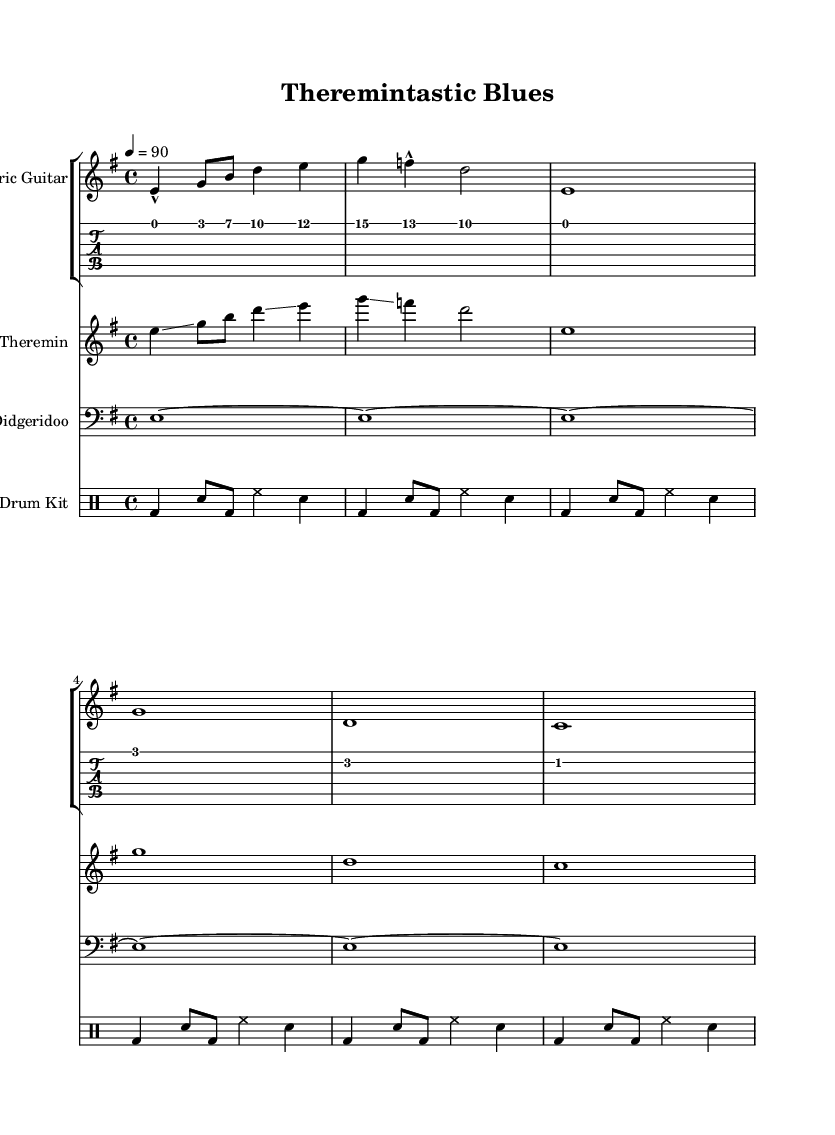What is the key signature of this music? The key signature is E minor, which contains one sharp (F#). This can be identified in the key signature section at the beginning of the score.
Answer: E minor What is the time signature of this music? The time signature is 4/4, which indicates four beats per measure. This is shown at the beginning of the score as well.
Answer: 4/4 What instrument is featured performing a glissando? The instrument performing a glissando is the theremin, indicated in the score where the glissando technique is marked in the melody.
Answer: Theremin How many measures are present in the electric guitar part? The electric guitar part consists of 6 measures, which can be counted by looking at the notation provided for the electric guitar staff section.
Answer: 6 What is the unique instrument used in this track besides the guitar? The unique instrument used is the didgeridoo, identified in the score by the instrument name at the beginning of its staff.
Answer: Didgeridoo Which instrument is associated with a clean sound and marked as "electric guitar"? The instrument associated with a clean sound is the electric guitar, as specified in the staff's instrument name.
Answer: Electric guitar What rhythmic pattern is used in the drum kit part? The rhythmic pattern in the drum kit part consists of alternating bass drum (bd) and snare (sn) notes, which creates a common backbeat typical in blues music.
Answer: Alternating bass drum and snare 